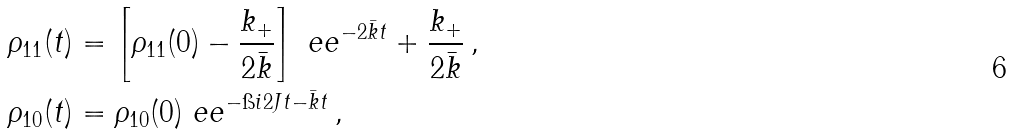Convert formula to latex. <formula><loc_0><loc_0><loc_500><loc_500>\rho _ { 1 1 } ( t ) & = \left [ \rho _ { 1 1 } ( 0 ) - \frac { k _ { + } } { 2 \bar { k } } \right ] \ e e ^ { - 2 \bar { k } t } + \frac { k _ { + } } { 2 \bar { k } } \, , \\ \rho _ { 1 0 } ( t ) & = \rho _ { 1 0 } ( 0 ) \ e e ^ { - \i i 2 J t - \bar { k } t } \, ,</formula> 